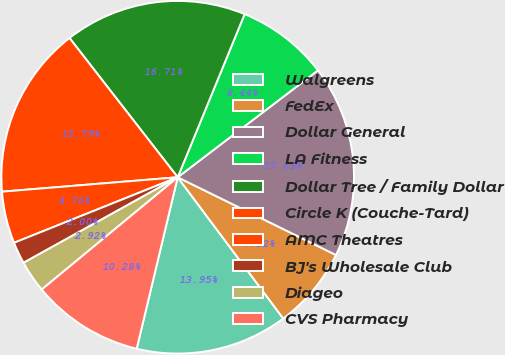<chart> <loc_0><loc_0><loc_500><loc_500><pie_chart><fcel>Walgreens<fcel>FedEx<fcel>Dollar General<fcel>LA Fitness<fcel>Dollar Tree / Family Dollar<fcel>Circle K (Couche-Tard)<fcel>AMC Theatres<fcel>BJ's Wholesale Club<fcel>Diageo<fcel>CVS Pharmacy<nl><fcel>13.95%<fcel>7.52%<fcel>17.63%<fcel>8.44%<fcel>16.71%<fcel>15.79%<fcel>4.76%<fcel>2.0%<fcel>2.92%<fcel>10.28%<nl></chart> 